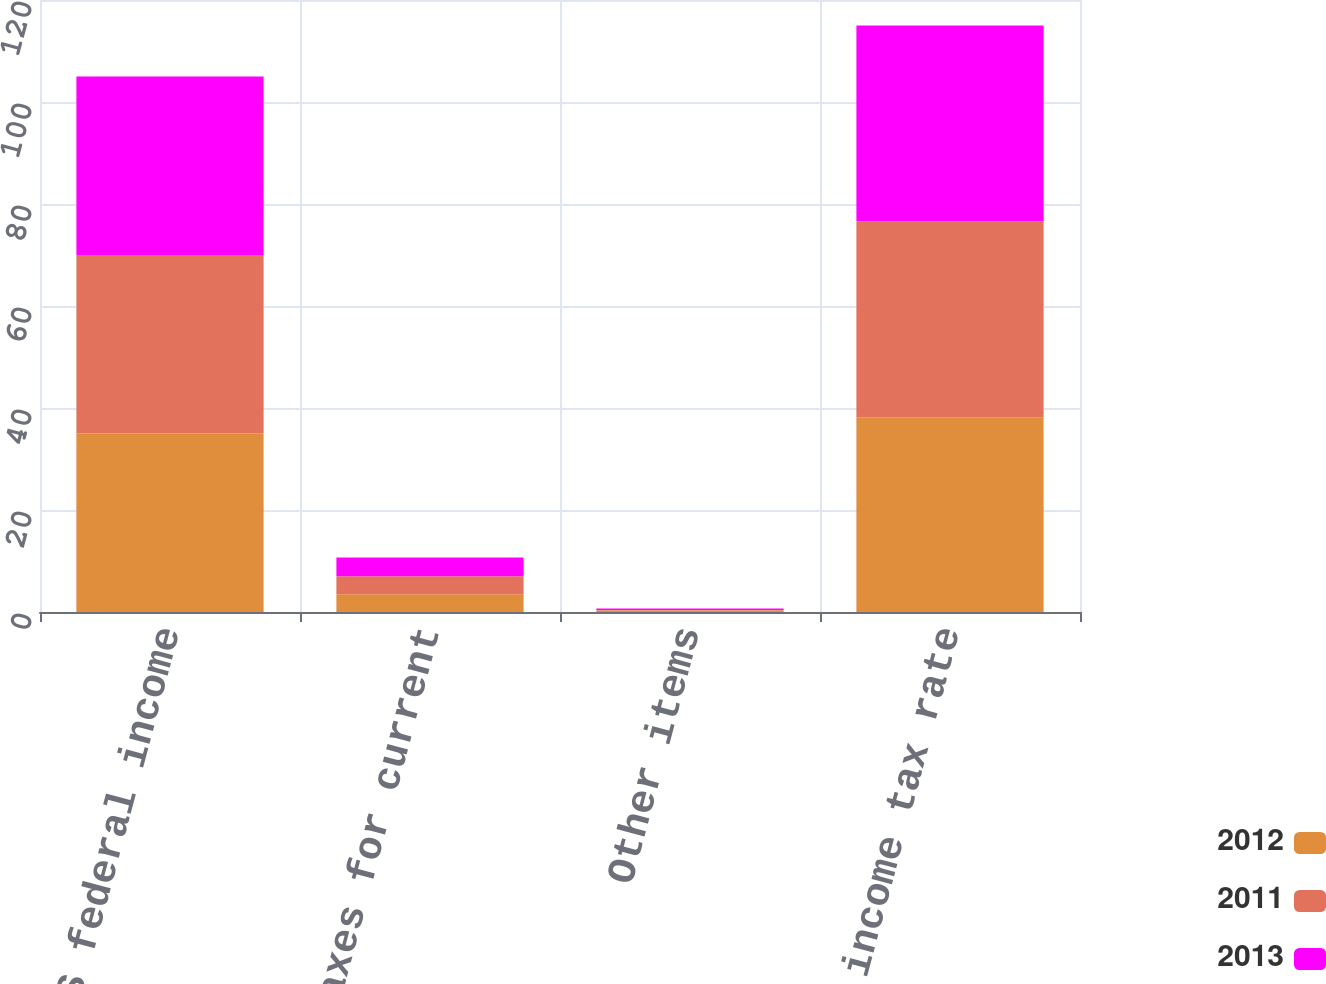Convert chart. <chart><loc_0><loc_0><loc_500><loc_500><stacked_bar_chart><ecel><fcel>Statutory US federal income<fcel>State income taxes for current<fcel>Other items<fcel>Effective income tax rate<nl><fcel>2012<fcel>35<fcel>3.5<fcel>0.3<fcel>38.2<nl><fcel>2011<fcel>35<fcel>3.5<fcel>0.1<fcel>38.4<nl><fcel>2013<fcel>35<fcel>3.7<fcel>0.3<fcel>38.4<nl></chart> 